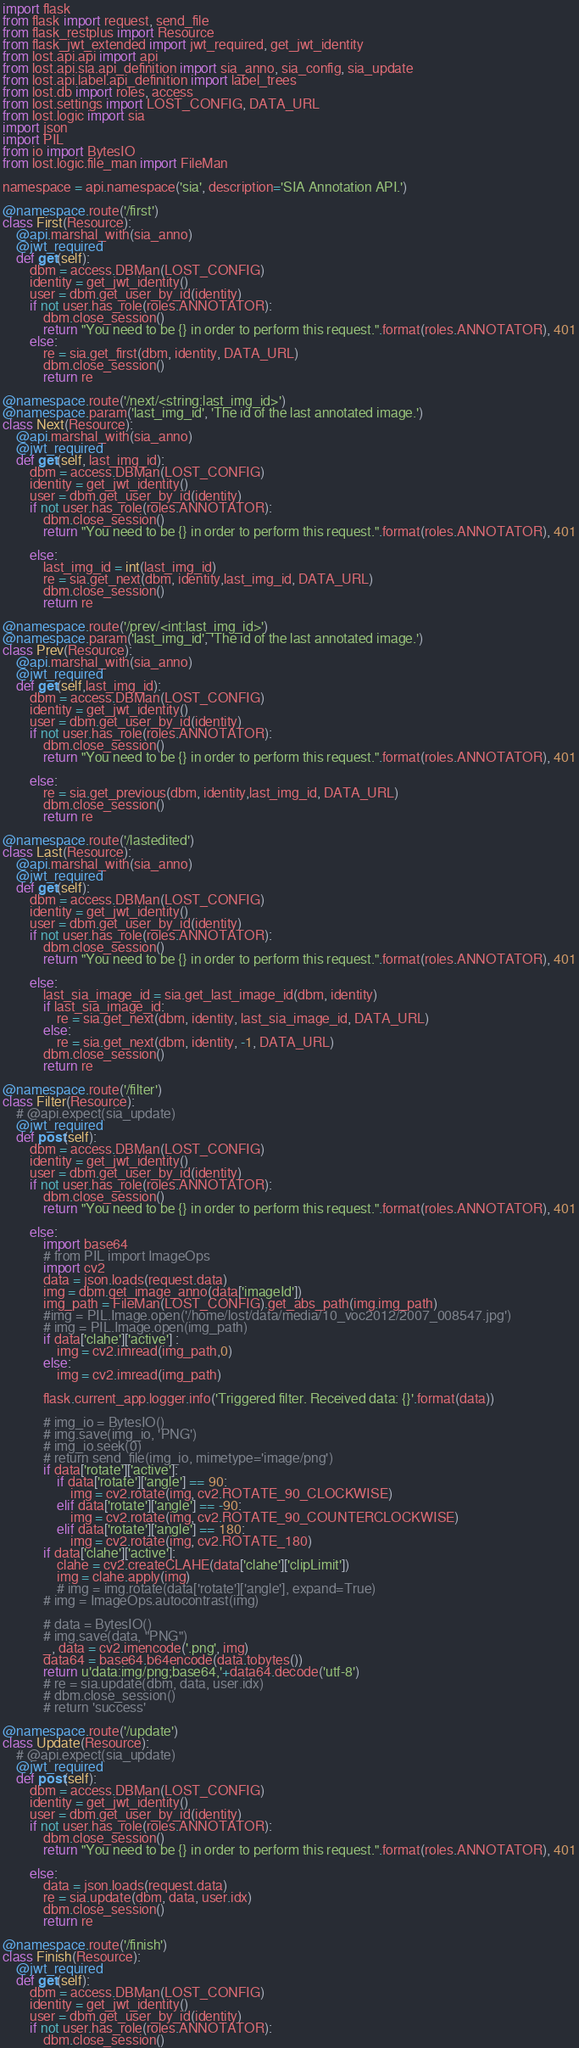Convert code to text. <code><loc_0><loc_0><loc_500><loc_500><_Python_>import flask
from flask import request, send_file
from flask_restplus import Resource
from flask_jwt_extended import jwt_required, get_jwt_identity
from lost.api.api import api
from lost.api.sia.api_definition import sia_anno, sia_config, sia_update
from lost.api.label.api_definition import label_trees
from lost.db import roles, access
from lost.settings import LOST_CONFIG, DATA_URL
from lost.logic import sia
import json
import PIL
from io import BytesIO
from lost.logic.file_man import FileMan

namespace = api.namespace('sia', description='SIA Annotation API.')

@namespace.route('/first')
class First(Resource):
    @api.marshal_with(sia_anno)
    @jwt_required 
    def get(self):
        dbm = access.DBMan(LOST_CONFIG)
        identity = get_jwt_identity()
        user = dbm.get_user_by_id(identity)
        if not user.has_role(roles.ANNOTATOR):
            dbm.close_session()
            return "You need to be {} in order to perform this request.".format(roles.ANNOTATOR), 401
        else:
            re = sia.get_first(dbm, identity, DATA_URL)
            dbm.close_session()
            return re

@namespace.route('/next/<string:last_img_id>')
@namespace.param('last_img_id', 'The id of the last annotated image.')
class Next(Resource):
    @api.marshal_with(sia_anno)
    @jwt_required 
    def get(self, last_img_id):
        dbm = access.DBMan(LOST_CONFIG)
        identity = get_jwt_identity()
        user = dbm.get_user_by_id(identity)
        if not user.has_role(roles.ANNOTATOR):
            dbm.close_session()
            return "You need to be {} in order to perform this request.".format(roles.ANNOTATOR), 401

        else:
            last_img_id = int(last_img_id)
            re = sia.get_next(dbm, identity,last_img_id, DATA_URL)
            dbm.close_session()
            return re

@namespace.route('/prev/<int:last_img_id>')
@namespace.param('last_img_id', 'The id of the last annotated image.')
class Prev(Resource):
    @api.marshal_with(sia_anno)
    @jwt_required 
    def get(self,last_img_id):
        dbm = access.DBMan(LOST_CONFIG)
        identity = get_jwt_identity()
        user = dbm.get_user_by_id(identity)
        if not user.has_role(roles.ANNOTATOR):
            dbm.close_session()
            return "You need to be {} in order to perform this request.".format(roles.ANNOTATOR), 401

        else:
            re = sia.get_previous(dbm, identity,last_img_id, DATA_URL)
            dbm.close_session()
            return re

@namespace.route('/lastedited')
class Last(Resource):
    @api.marshal_with(sia_anno)
    @jwt_required 
    def get(self):
        dbm = access.DBMan(LOST_CONFIG)
        identity = get_jwt_identity()
        user = dbm.get_user_by_id(identity)
        if not user.has_role(roles.ANNOTATOR):
            dbm.close_session()
            return "You need to be {} in order to perform this request.".format(roles.ANNOTATOR), 401

        else:
            last_sia_image_id = sia.get_last_image_id(dbm, identity)
            if last_sia_image_id:
                re = sia.get_next(dbm, identity, last_sia_image_id, DATA_URL)
            else:
                re = sia.get_next(dbm, identity, -1, DATA_URL)
            dbm.close_session()
            return re

@namespace.route('/filter')
class Filter(Resource):
    # @api.expect(sia_update)
    @jwt_required 
    def post(self):
        dbm = access.DBMan(LOST_CONFIG)
        identity = get_jwt_identity()
        user = dbm.get_user_by_id(identity)
        if not user.has_role(roles.ANNOTATOR):
            dbm.close_session()
            return "You need to be {} in order to perform this request.".format(roles.ANNOTATOR), 401

        else:
            import base64
            # from PIL import ImageOps
            import cv2
            data = json.loads(request.data)
            img = dbm.get_image_anno(data['imageId'])
            img_path = FileMan(LOST_CONFIG).get_abs_path(img.img_path)
            #img = PIL.Image.open('/home/lost/data/media/10_voc2012/2007_008547.jpg')
            # img = PIL.Image.open(img_path)
            if data['clahe']['active'] :
                img = cv2.imread(img_path,0)
            else:
                img = cv2.imread(img_path)
                
            flask.current_app.logger.info('Triggered filter. Received data: {}'.format(data))

            # img_io = BytesIO()
            # img.save(img_io, 'PNG')
            # img_io.seek(0)
            # return send_file(img_io, mimetype='image/png')
            if data['rotate']['active']:
                if data['rotate']['angle'] == 90:
                    img = cv2.rotate(img, cv2.ROTATE_90_CLOCKWISE)
                elif data['rotate']['angle'] == -90:
                    img = cv2.rotate(img, cv2.ROTATE_90_COUNTERCLOCKWISE)
                elif data['rotate']['angle'] == 180:
                    img = cv2.rotate(img, cv2.ROTATE_180)
            if data['clahe']['active']:
                clahe = cv2.createCLAHE(data['clahe']['clipLimit'])
                img = clahe.apply(img)
                # img = img.rotate(data['rotate']['angle'], expand=True)
            # img = ImageOps.autocontrast(img)

            # data = BytesIO()
            # img.save(data, "PNG")
            _, data = cv2.imencode('.png', img)
            data64 = base64.b64encode(data.tobytes())
            return u'data:img/png;base64,'+data64.decode('utf-8')
            # re = sia.update(dbm, data, user.idx)
            # dbm.close_session()
            # return 'success'

@namespace.route('/update')
class Update(Resource):
    # @api.expect(sia_update)
    @jwt_required 
    def post(self):
        dbm = access.DBMan(LOST_CONFIG)
        identity = get_jwt_identity()
        user = dbm.get_user_by_id(identity)
        if not user.has_role(roles.ANNOTATOR):
            dbm.close_session()
            return "You need to be {} in order to perform this request.".format(roles.ANNOTATOR), 401

        else:
            data = json.loads(request.data)
            re = sia.update(dbm, data, user.idx)
            dbm.close_session()
            return re

@namespace.route('/finish')
class Finish(Resource):
    @jwt_required 
    def get(self):
        dbm = access.DBMan(LOST_CONFIG)
        identity = get_jwt_identity()
        user = dbm.get_user_by_id(identity)
        if not user.has_role(roles.ANNOTATOR):
            dbm.close_session()</code> 